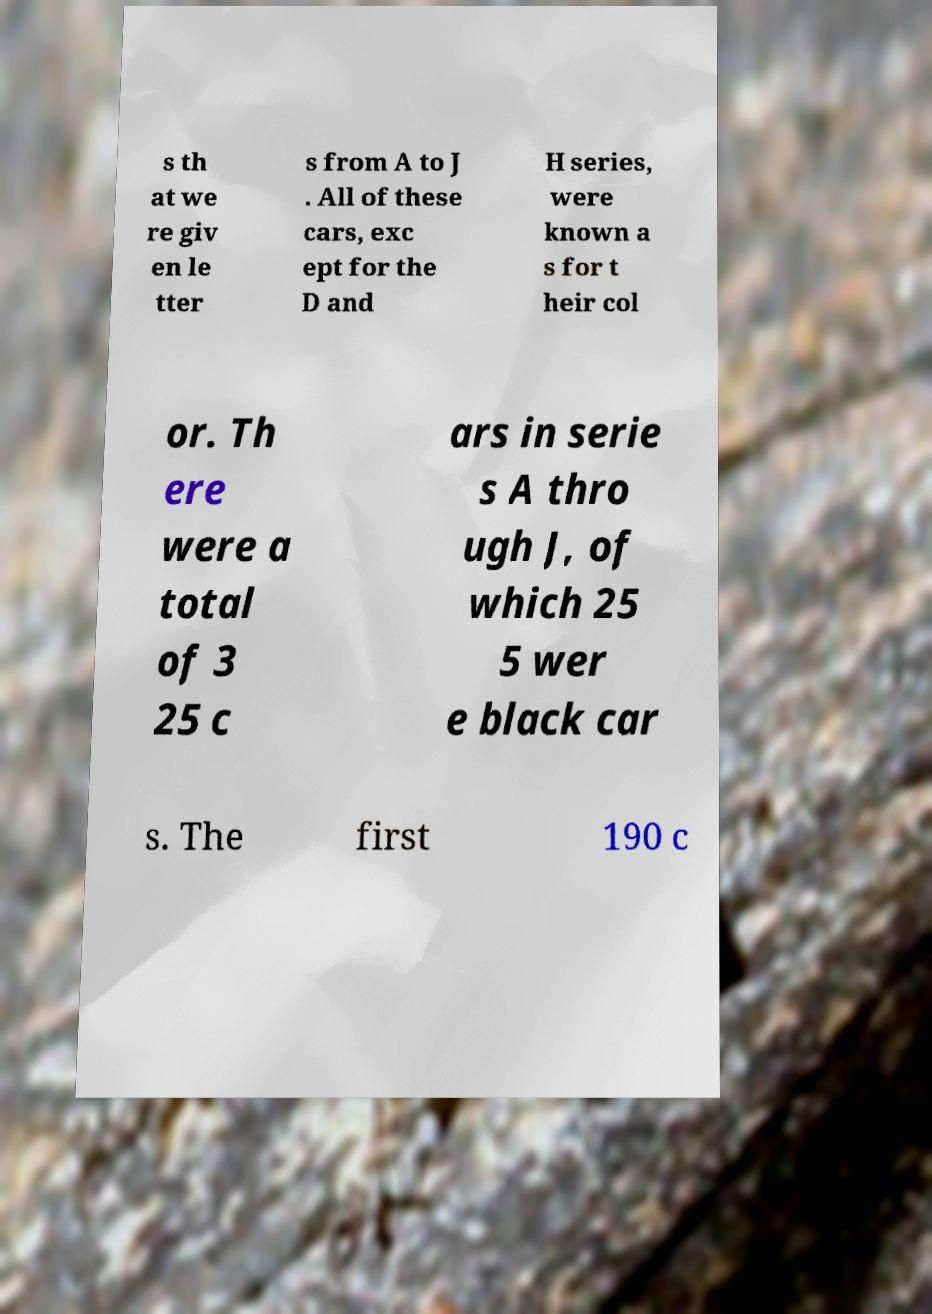Please read and relay the text visible in this image. What does it say? s th at we re giv en le tter s from A to J . All of these cars, exc ept for the D and H series, were known a s for t heir col or. Th ere were a total of 3 25 c ars in serie s A thro ugh J, of which 25 5 wer e black car s. The first 190 c 